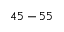Convert formula to latex. <formula><loc_0><loc_0><loc_500><loc_500>4 5 - 5 5</formula> 